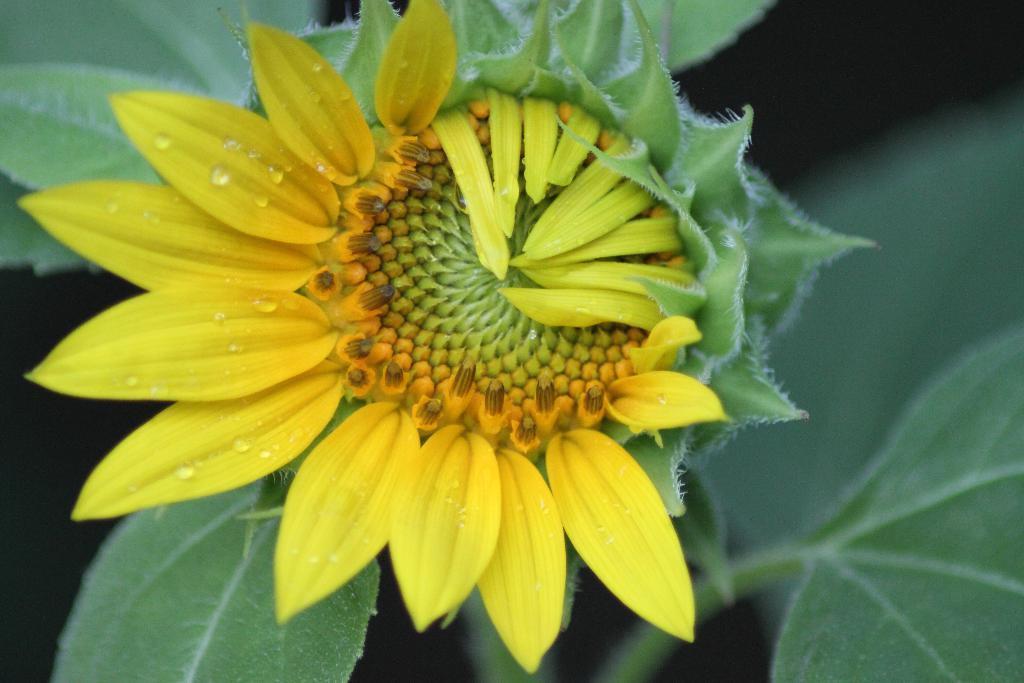In one or two sentences, can you explain what this image depicts? In the image there is a plant with yellow sunflower on it. 